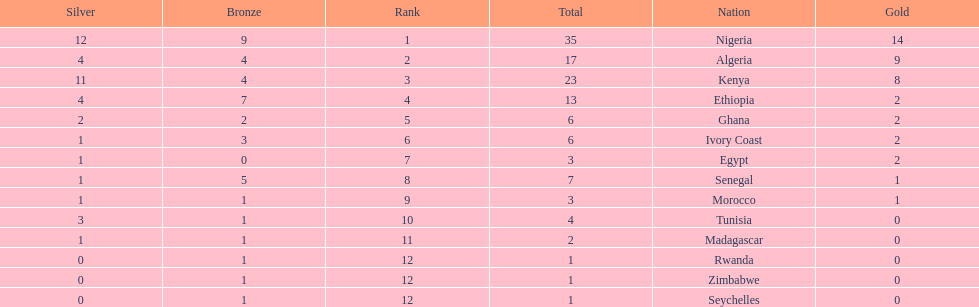What is the name of the only nation that did not earn any bronze medals? Egypt. 